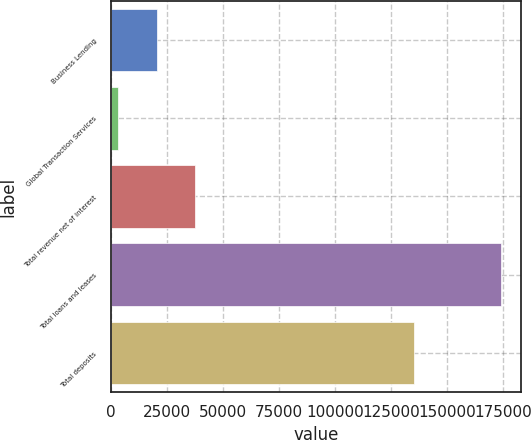<chart> <loc_0><loc_0><loc_500><loc_500><bar_chart><fcel>Business Lending<fcel>Global Transaction Services<fcel>Total revenue net of interest<fcel>Total loans and leases<fcel>Total deposits<nl><fcel>20387.1<fcel>3288<fcel>37486.2<fcel>174279<fcel>135337<nl></chart> 